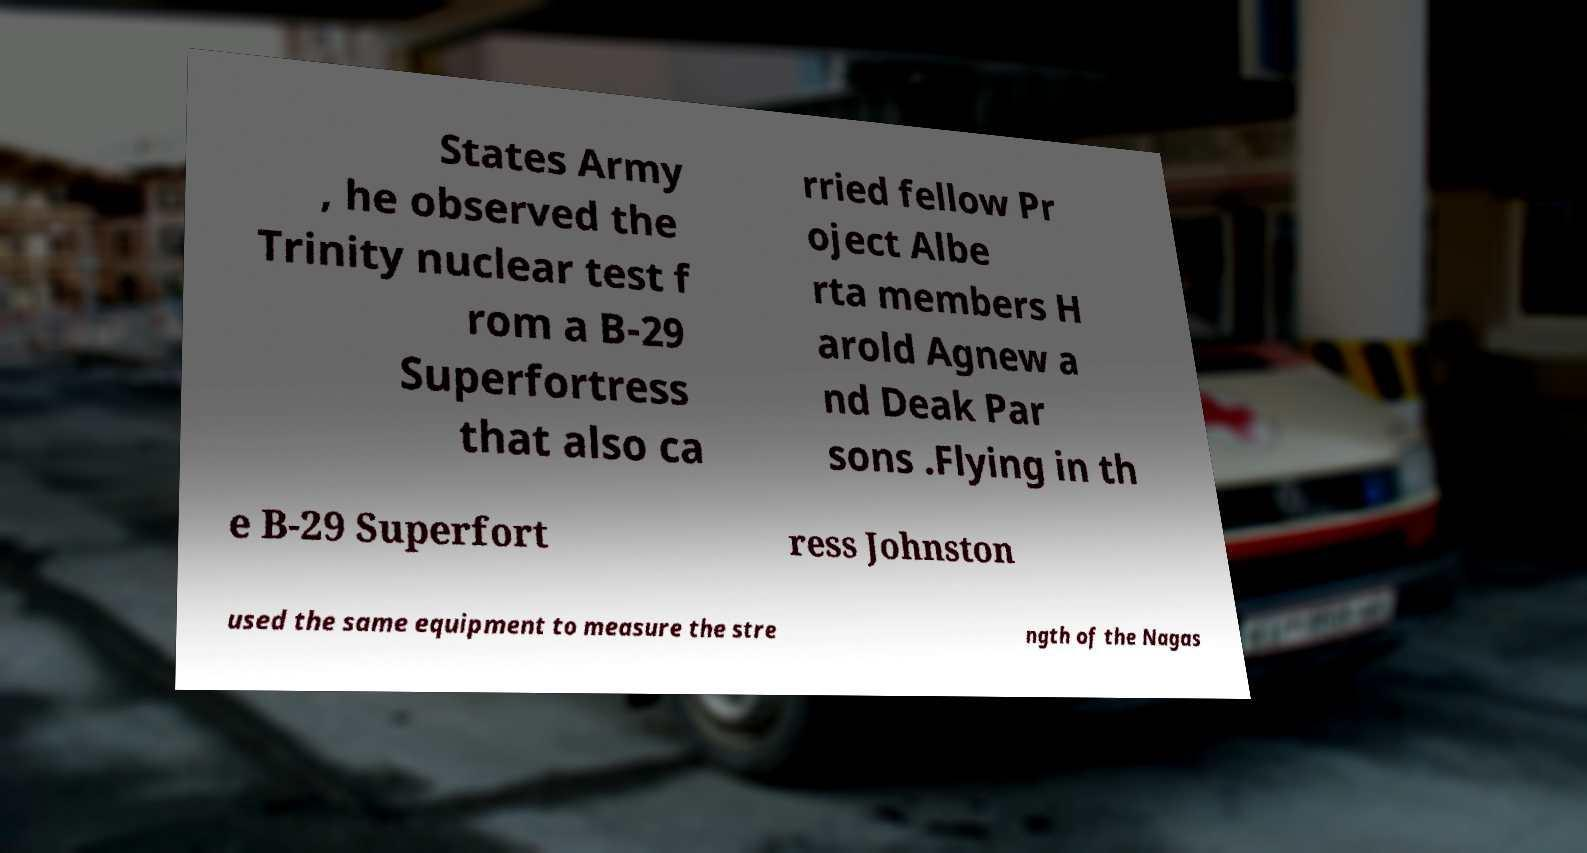There's text embedded in this image that I need extracted. Can you transcribe it verbatim? States Army , he observed the Trinity nuclear test f rom a B-29 Superfortress that also ca rried fellow Pr oject Albe rta members H arold Agnew a nd Deak Par sons .Flying in th e B-29 Superfort ress Johnston used the same equipment to measure the stre ngth of the Nagas 